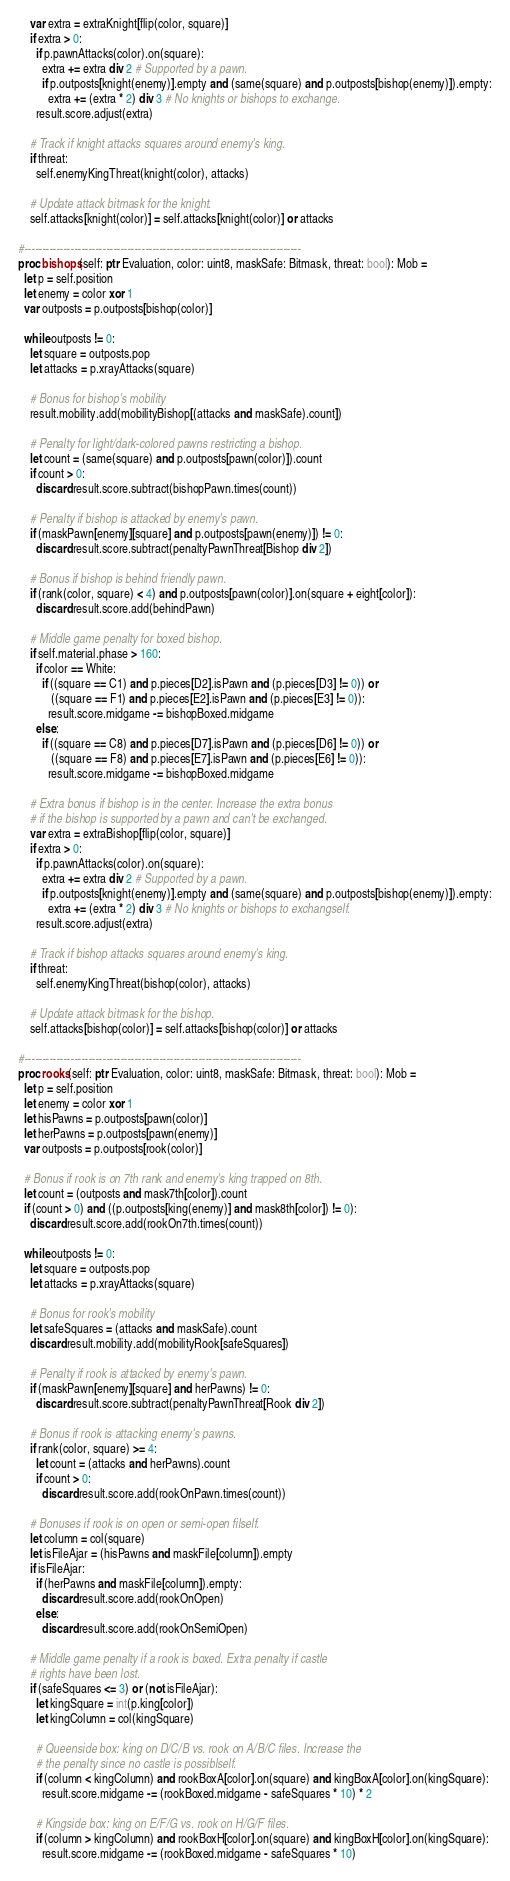Convert code to text. <code><loc_0><loc_0><loc_500><loc_500><_Nim_>    var extra = extraKnight[flip(color, square)]
    if extra > 0:
      if p.pawnAttacks(color).on(square):
        extra += extra div 2 # Supported by a pawn.
        if p.outposts[knight(enemy)].empty and (same(square) and p.outposts[bishop(enemy)]).empty:
          extra += (extra * 2) div 3 # No knights or bishops to exchange.
      result.score.adjust(extra)

    # Track if knight attacks squares around enemy's king.
    if threat:
      self.enemyKingThreat(knight(color), attacks)

    # Update attack bitmask for the knight.
    self.attacks[knight(color)] = self.attacks[knight(color)] or attacks

#------------------------------------------------------------------------------
proc bishops(self: ptr Evaluation, color: uint8, maskSafe: Bitmask, threat: bool): Mob =
  let p = self.position
  let enemy = color xor 1
  var outposts = p.outposts[bishop(color)]

  while outposts != 0:
    let square = outposts.pop
    let attacks = p.xrayAttacks(square)

    # Bonus for bishop's mobility
    result.mobility.add(mobilityBishop[(attacks and maskSafe).count])

    # Penalty for light/dark-colored pawns restricting a bishop.
    let count = (same(square) and p.outposts[pawn(color)]).count
    if count > 0:
      discard result.score.subtract(bishopPawn.times(count))

    # Penalty if bishop is attacked by enemy's pawn.
    if (maskPawn[enemy][square] and p.outposts[pawn(enemy)]) != 0:
      discard result.score.subtract(penaltyPawnThreat[Bishop div 2])

    # Bonus if bishop is behind friendly pawn.
    if (rank(color, square) < 4) and p.outposts[pawn(color)].on(square + eight[color]):
      discard result.score.add(behindPawn)

    # Middle game penalty for boxed bishop.
    if self.material.phase > 160:
      if color == White:
        if ((square == C1) and p.pieces[D2].isPawn and (p.pieces[D3] != 0)) or
           ((square == F1) and p.pieces[E2].isPawn and (p.pieces[E3] != 0)):
          result.score.midgame -= bishopBoxed.midgame
      else:
        if ((square == C8) and p.pieces[D7].isPawn and (p.pieces[D6] != 0)) or
           ((square == F8) and p.pieces[E7].isPawn and (p.pieces[E6] != 0)):
          result.score.midgame -= bishopBoxed.midgame

    # Extra bonus if bishop is in the center. Increase the extra bonus
    # if the bishop is supported by a pawn and can't be exchanged.
    var extra = extraBishop[flip(color, square)]
    if extra > 0:
      if p.pawnAttacks(color).on(square):
        extra += extra div 2 # Supported by a pawn.
        if p.outposts[knight(enemy)].empty and (same(square) and p.outposts[bishop(enemy)]).empty:
          extra += (extra * 2) div 3 # No knights or bishops to exchangself.
      result.score.adjust(extra)

    # Track if bishop attacks squares around enemy's king.
    if threat:
      self.enemyKingThreat(bishop(color), attacks)

    # Update attack bitmask for the bishop.
    self.attacks[bishop(color)] = self.attacks[bishop(color)] or attacks

#------------------------------------------------------------------------------
proc rooks(self: ptr Evaluation, color: uint8, maskSafe: Bitmask, threat: bool): Mob =
  let p = self.position
  let enemy = color xor 1
  let hisPawns = p.outposts[pawn(color)]
  let herPawns = p.outposts[pawn(enemy)]
  var outposts = p.outposts[rook(color)]

  # Bonus if rook is on 7th rank and enemy's king trapped on 8th.
  let count = (outposts and mask7th[color]).count
  if (count > 0) and ((p.outposts[king(enemy)] and mask8th[color]) != 0):
    discard result.score.add(rookOn7th.times(count))

  while outposts != 0:
    let square = outposts.pop
    let attacks = p.xrayAttacks(square)

    # Bonus for rook's mobility
    let safeSquares = (attacks and maskSafe).count
    discard result.mobility.add(mobilityRook[safeSquares])

    # Penalty if rook is attacked by enemy's pawn.
    if (maskPawn[enemy][square] and herPawns) != 0:
      discard result.score.subtract(penaltyPawnThreat[Rook div 2])

    # Bonus if rook is attacking enemy's pawns.
    if rank(color, square) >= 4:
      let count = (attacks and herPawns).count
      if count > 0:
        discard result.score.add(rookOnPawn.times(count))

    # Bonuses if rook is on open or semi-open filself.
    let column = col(square)
    let isFileAjar = (hisPawns and maskFile[column]).empty
    if isFileAjar:
      if (herPawns and maskFile[column]).empty:
        discard result.score.add(rookOnOpen)
      else:
        discard result.score.add(rookOnSemiOpen)

    # Middle game penalty if a rook is boxed. Extra penalty if castle
    # rights have been lost.
    if (safeSquares <= 3) or (not isFileAjar):
      let kingSquare = int(p.king[color])
      let kingColumn = col(kingSquare)

      # Queenside box: king on D/C/B vs. rook on A/B/C files. Increase the
      # the penalty since no castle is possiblself.
      if (column < kingColumn) and rookBoxA[color].on(square) and kingBoxA[color].on(kingSquare):
        result.score.midgame -= (rookBoxed.midgame - safeSquares * 10) * 2

      # Kingside box: king on E/F/G vs. rook on H/G/F files.
      if (column > kingColumn) and rookBoxH[color].on(square) and kingBoxH[color].on(kingSquare):
        result.score.midgame -= (rookBoxed.midgame - safeSquares * 10)</code> 